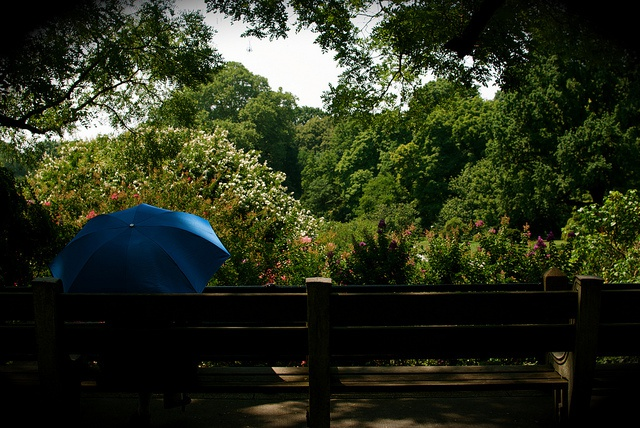Describe the objects in this image and their specific colors. I can see bench in black, olive, and gray tones, umbrella in black, navy, lightblue, and blue tones, and people in black tones in this image. 